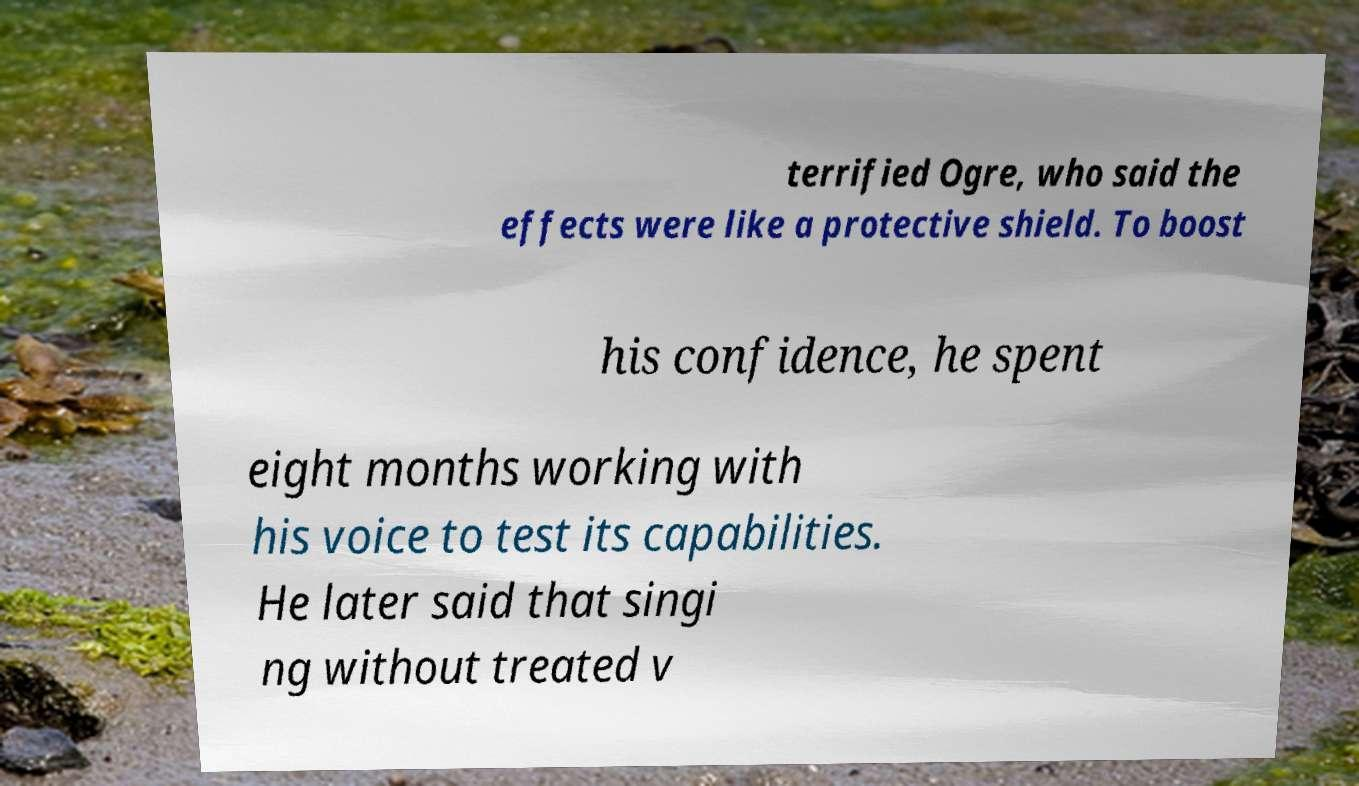Please identify and transcribe the text found in this image. terrified Ogre, who said the effects were like a protective shield. To boost his confidence, he spent eight months working with his voice to test its capabilities. He later said that singi ng without treated v 